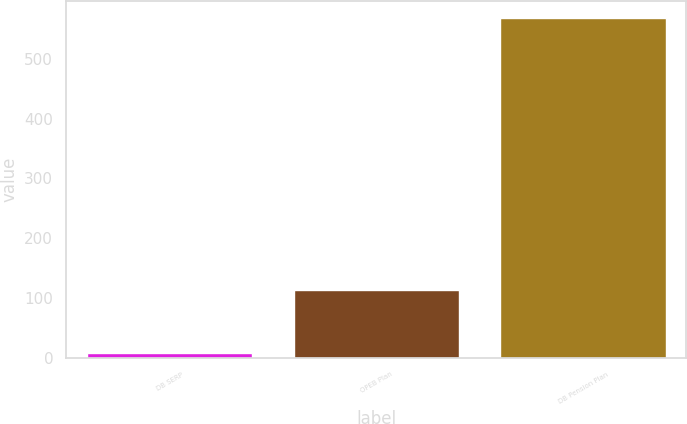<chart> <loc_0><loc_0><loc_500><loc_500><bar_chart><fcel>DB SERP<fcel>OPEB Plan<fcel>DB Pension Plan<nl><fcel>8<fcel>113<fcel>568<nl></chart> 